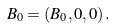<formula> <loc_0><loc_0><loc_500><loc_500>B _ { 0 } = \left ( B _ { 0 } , 0 , 0 \right ) .</formula> 